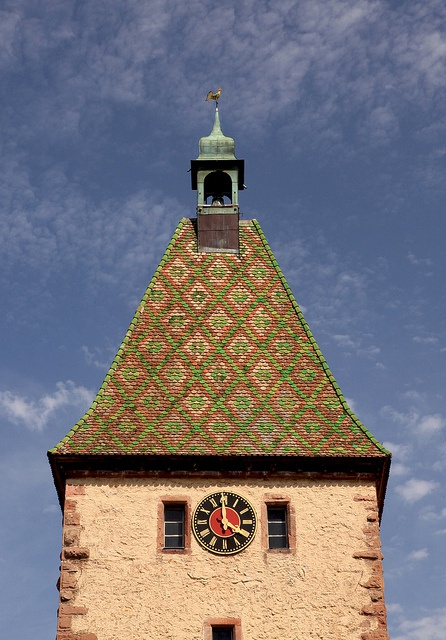Describe the objects in this image and their specific colors. I can see a clock in blue, black, khaki, brown, and tan tones in this image. 